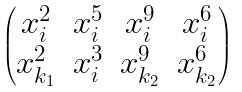Convert formula to latex. <formula><loc_0><loc_0><loc_500><loc_500>\begin{pmatrix} x _ { i } ^ { 2 } & x _ { i } ^ { 5 } & x _ { i } ^ { 9 } & x _ { i } ^ { 6 } \\ x _ { k _ { 1 } } ^ { 2 } & x _ { i } ^ { 3 } & x _ { k _ { 2 } } ^ { 9 } & x _ { k _ { 2 } } ^ { 6 } \end{pmatrix}</formula> 